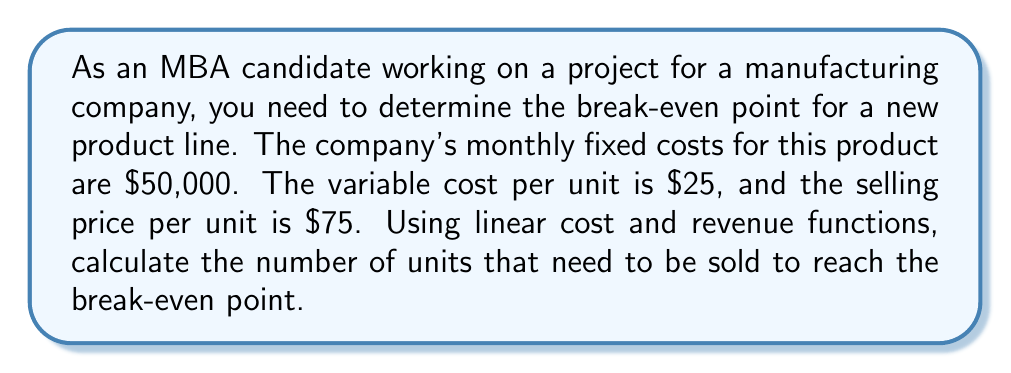Solve this math problem. To solve this problem, we'll use the concept of linear cost and revenue functions and the break-even point formula.

1. Define the variables:
   Let $x$ be the number of units sold
   Let $FC$ be the fixed costs
   Let $VC$ be the variable cost per unit
   Let $P$ be the selling price per unit

2. Set up the linear cost function:
   Total Cost (TC) = Fixed Costs + (Variable Cost per unit × Number of units)
   $$TC = FC + VC \times x$$
   $$TC = 50000 + 25x$$

3. Set up the linear revenue function:
   Total Revenue (TR) = Selling Price per unit × Number of units
   $$TR = P \times x$$
   $$TR = 75x$$

4. At the break-even point, Total Cost equals Total Revenue:
   $$TC = TR$$
   $$50000 + 25x = 75x$$

5. Solve for x:
   $$50000 = 75x - 25x$$
   $$50000 = 50x$$
   $$x = \frac{50000}{50} = 1000$$

Therefore, the company needs to sell 1000 units to reach the break-even point.

To verify:
At 1000 units:
Total Cost = $50000 + (25 × 1000) = $75000
Total Revenue = 75 × 1000 = $75000

Indeed, TC = TR at 1000 units, confirming the break-even point.
Answer: The break-even point is 1000 units. 